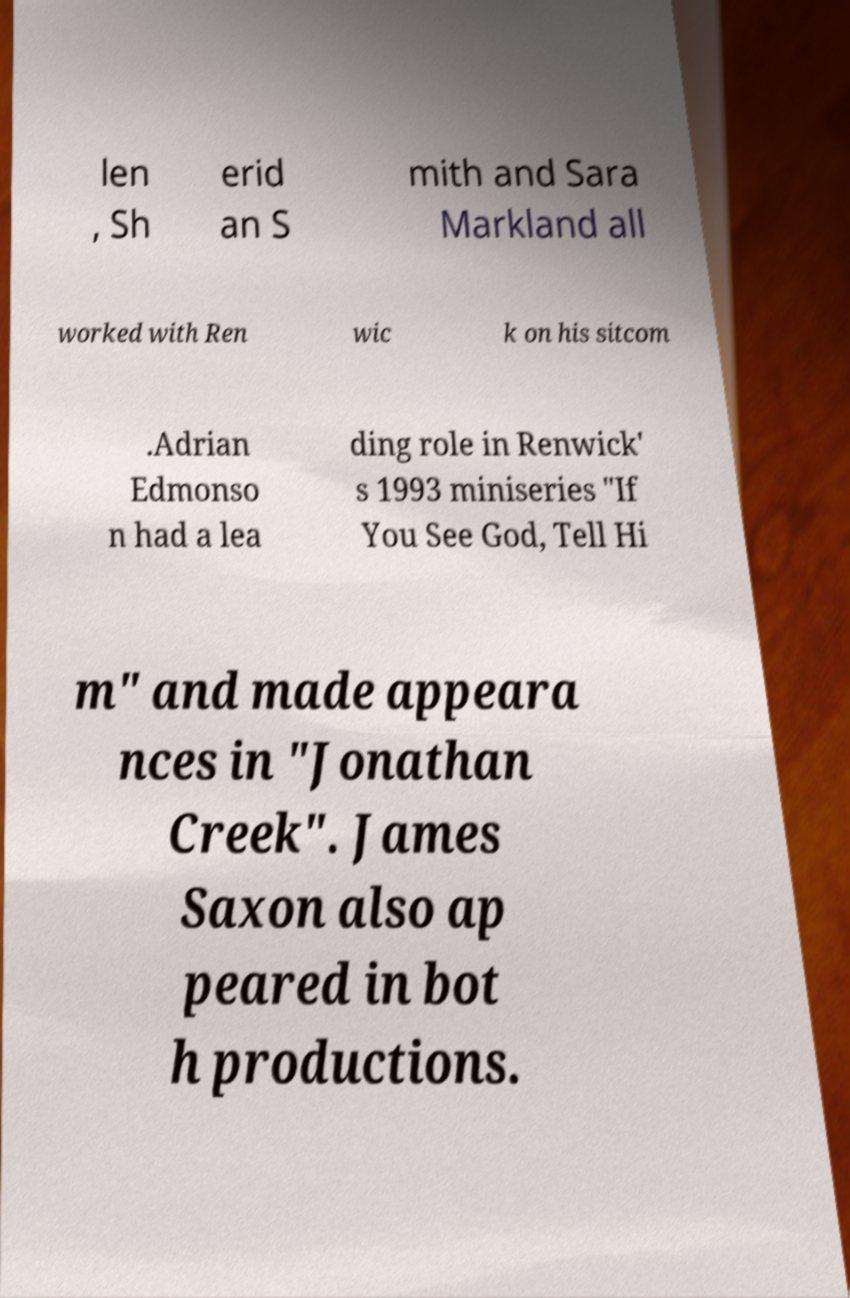Please identify and transcribe the text found in this image. len , Sh erid an S mith and Sara Markland all worked with Ren wic k on his sitcom .Adrian Edmonso n had a lea ding role in Renwick' s 1993 miniseries "If You See God, Tell Hi m" and made appeara nces in "Jonathan Creek". James Saxon also ap peared in bot h productions. 